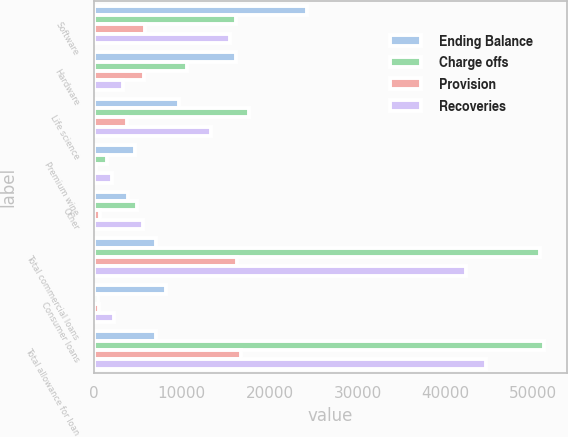Convert chart. <chart><loc_0><loc_0><loc_500><loc_500><stacked_bar_chart><ecel><fcel>Software<fcel>Hardware<fcel>Life science<fcel>Premium wine<fcel>Other<fcel>Total commercial loans<fcel>Consumer loans<fcel>Total allowance for loan<nl><fcel>Ending Balance<fcel>24209<fcel>16194<fcel>9651<fcel>4652<fcel>3877<fcel>7020.5<fcel>8203<fcel>7020.5<nl><fcel>Charge offs<fcel>16230<fcel>10568<fcel>17629<fcel>1457<fcel>4866<fcel>50750<fcel>489<fcel>51239<nl><fcel>Provision<fcel>5838<fcel>5715<fcel>3738<fcel>222<fcel>737<fcel>16250<fcel>538<fcel>16788<nl><fcel>Recoveries<fcel>15471<fcel>3347<fcel>13317<fcel>2075<fcel>5570<fcel>42357<fcel>2271<fcel>44628<nl></chart> 